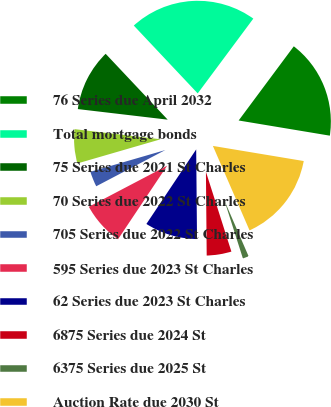Convert chart. <chart><loc_0><loc_0><loc_500><loc_500><pie_chart><fcel>76 Series due April 2032<fcel>Total mortgage bonds<fcel>75 Series due 2021 St Charles<fcel>70 Series due 2022 St Charles<fcel>705 Series due 2022 St Charles<fcel>595 Series due 2023 St Charles<fcel>62 Series due 2023 St Charles<fcel>6875 Series due 2024 St<fcel>6375 Series due 2025 St<fcel>Auction Rate due 2030 St<nl><fcel>17.45%<fcel>22.2%<fcel>11.11%<fcel>6.36%<fcel>3.19%<fcel>7.94%<fcel>9.52%<fcel>4.77%<fcel>1.6%<fcel>15.86%<nl></chart> 